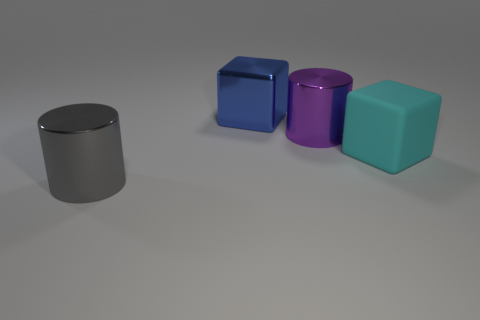What is the material of the big cyan object that is the same shape as the blue thing?
Offer a terse response. Rubber. What number of other things are the same size as the gray metal thing?
Offer a very short reply. 3. There is a large metallic thing that is left of the big shiny block; does it have the same shape as the large purple thing?
Offer a very short reply. Yes. The thing that is behind the large purple shiny cylinder has what shape?
Provide a succinct answer. Cube. Is there a big gray thing made of the same material as the purple cylinder?
Provide a succinct answer. Yes. How big is the purple cylinder?
Provide a succinct answer. Large. Is there a metallic thing to the left of the big metallic cylinder that is right of the metal cylinder that is in front of the large cyan thing?
Ensure brevity in your answer.  Yes. What number of cyan blocks are left of the blue shiny cube?
Offer a terse response. 0. What number of metallic blocks are the same color as the large matte cube?
Offer a very short reply. 0. How many objects are either big cylinders on the right side of the gray cylinder or big metallic things that are in front of the large cyan rubber cube?
Provide a succinct answer. 2. 